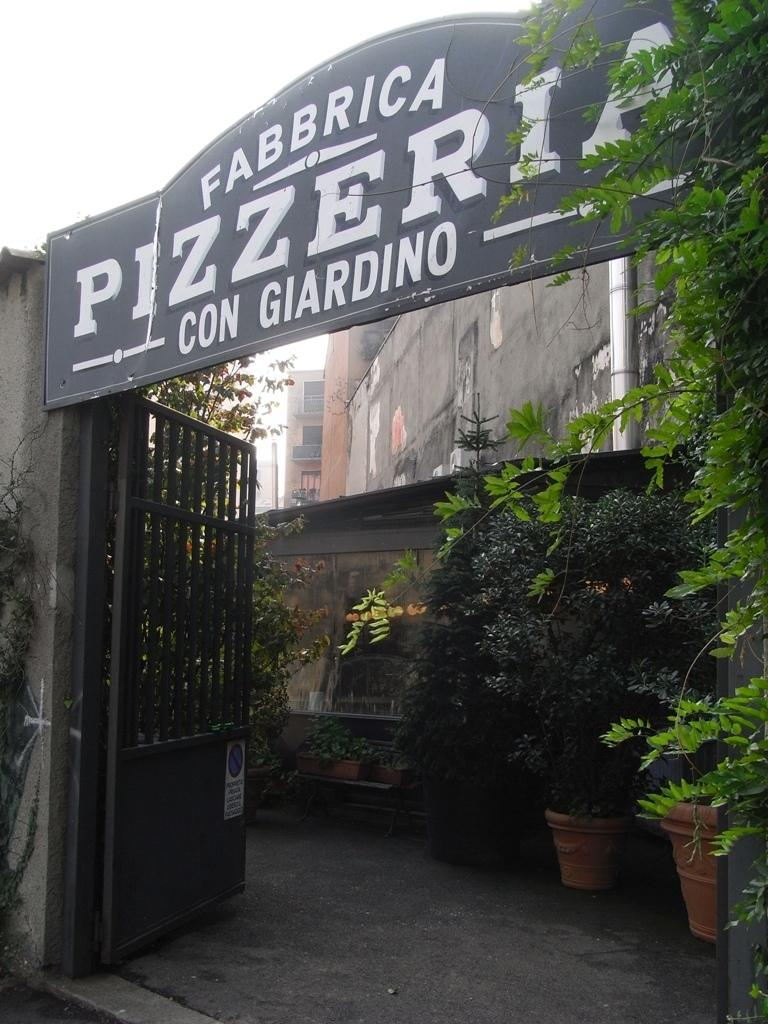What is the main object in the image? There is a name board in the image. What is the name board attached to? The name board is attached to a gate in the image. What type of structures can be seen in the image? There are buildings, a gate, and a wall in the image. What can be found on the floor in the image? There is a house plant on the floor in the image. What type of vegetation is present in the image? There are trees in the image. What architectural features can be seen in the image? There are windows in the image. What part of the natural environment is visible in the image? The sky is visible in the image. How many eggs are being used to kiss the wall in the image? There are no eggs or kissing depicted in the image; it features a name board, a gate, buildings, a house plant, trees, windows, and the sky. 